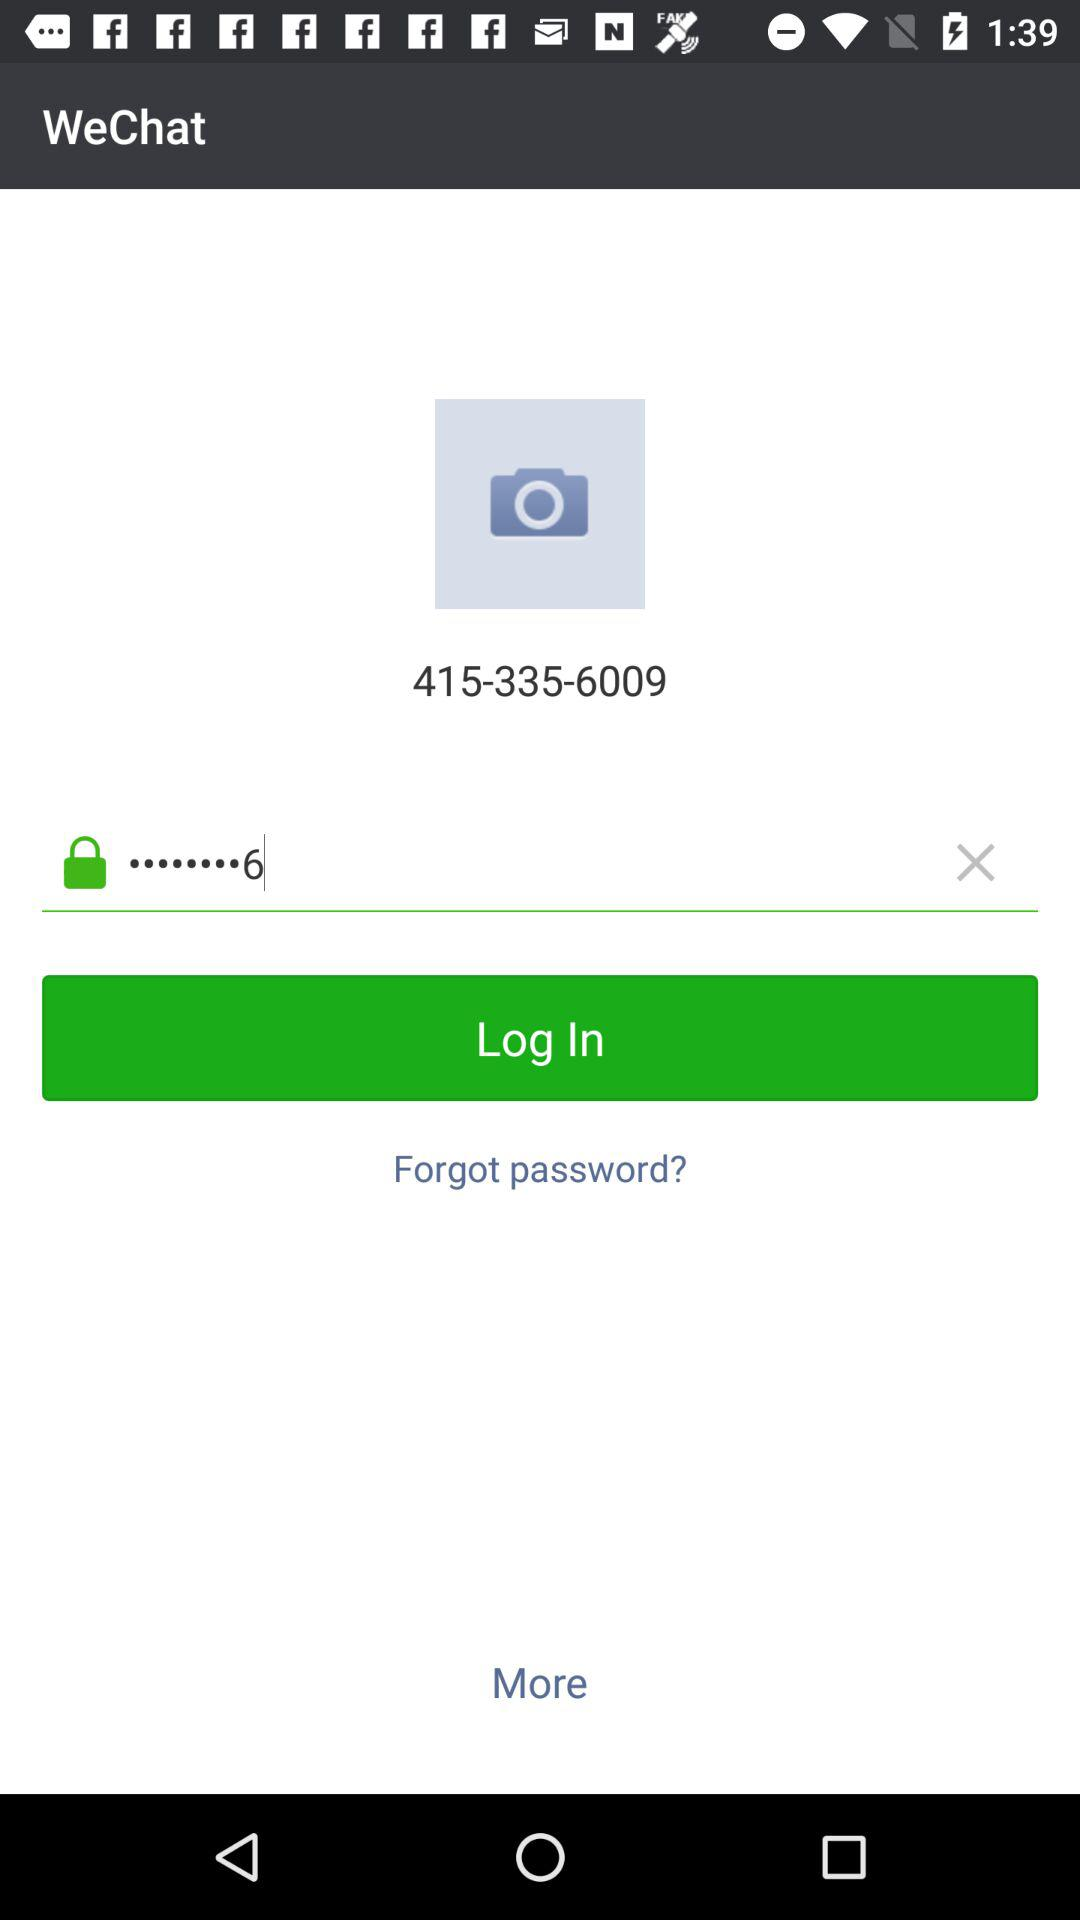What is the phone number? The phone number is 415-335-6009. 